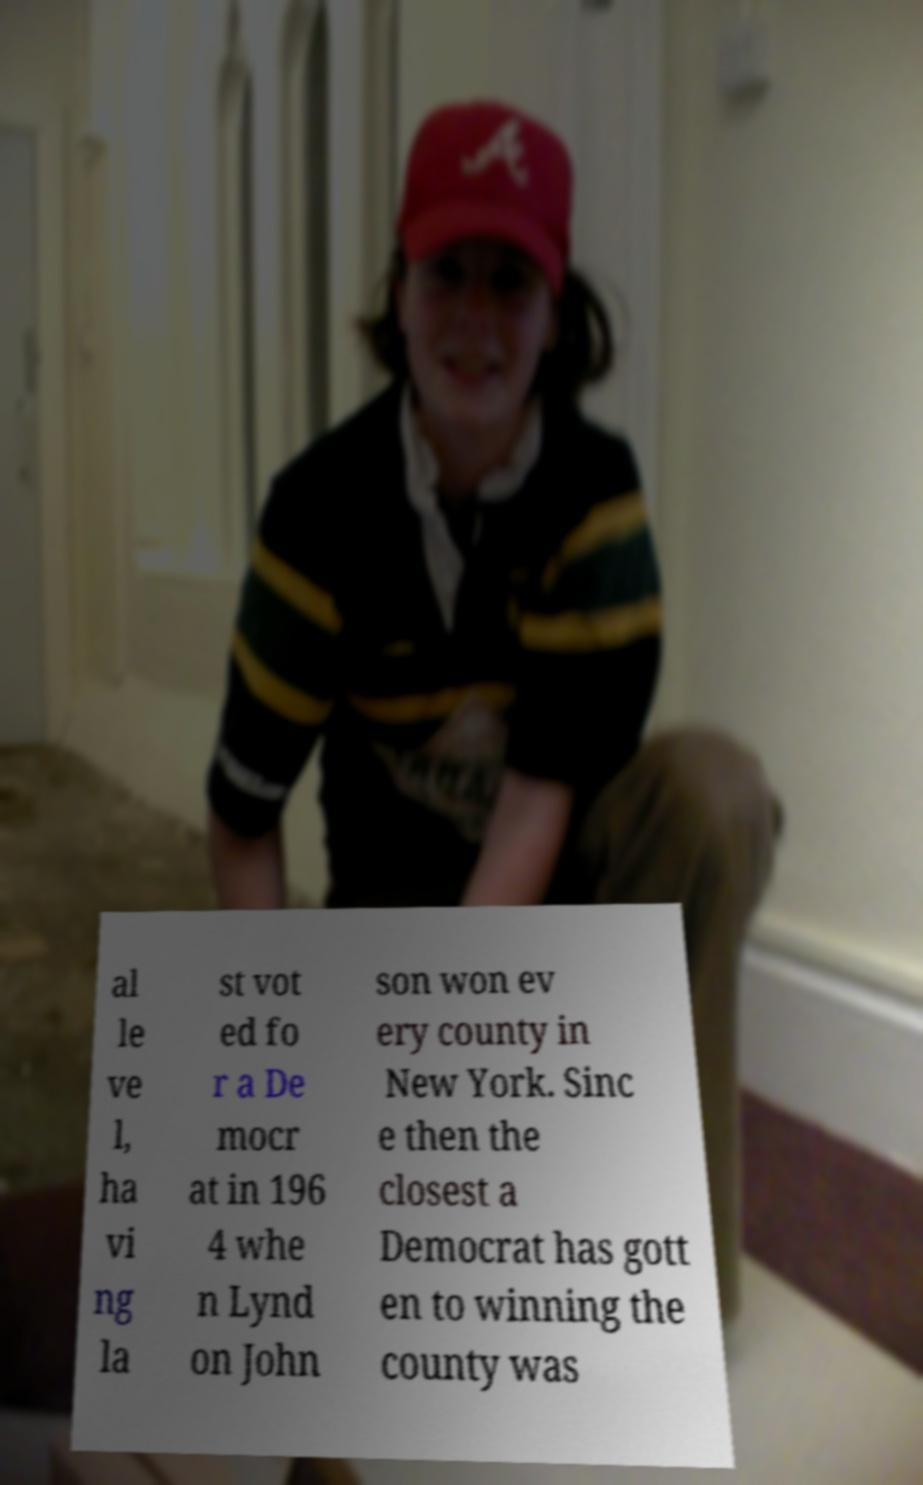Can you accurately transcribe the text from the provided image for me? al le ve l, ha vi ng la st vot ed fo r a De mocr at in 196 4 whe n Lynd on John son won ev ery county in New York. Sinc e then the closest a Democrat has gott en to winning the county was 